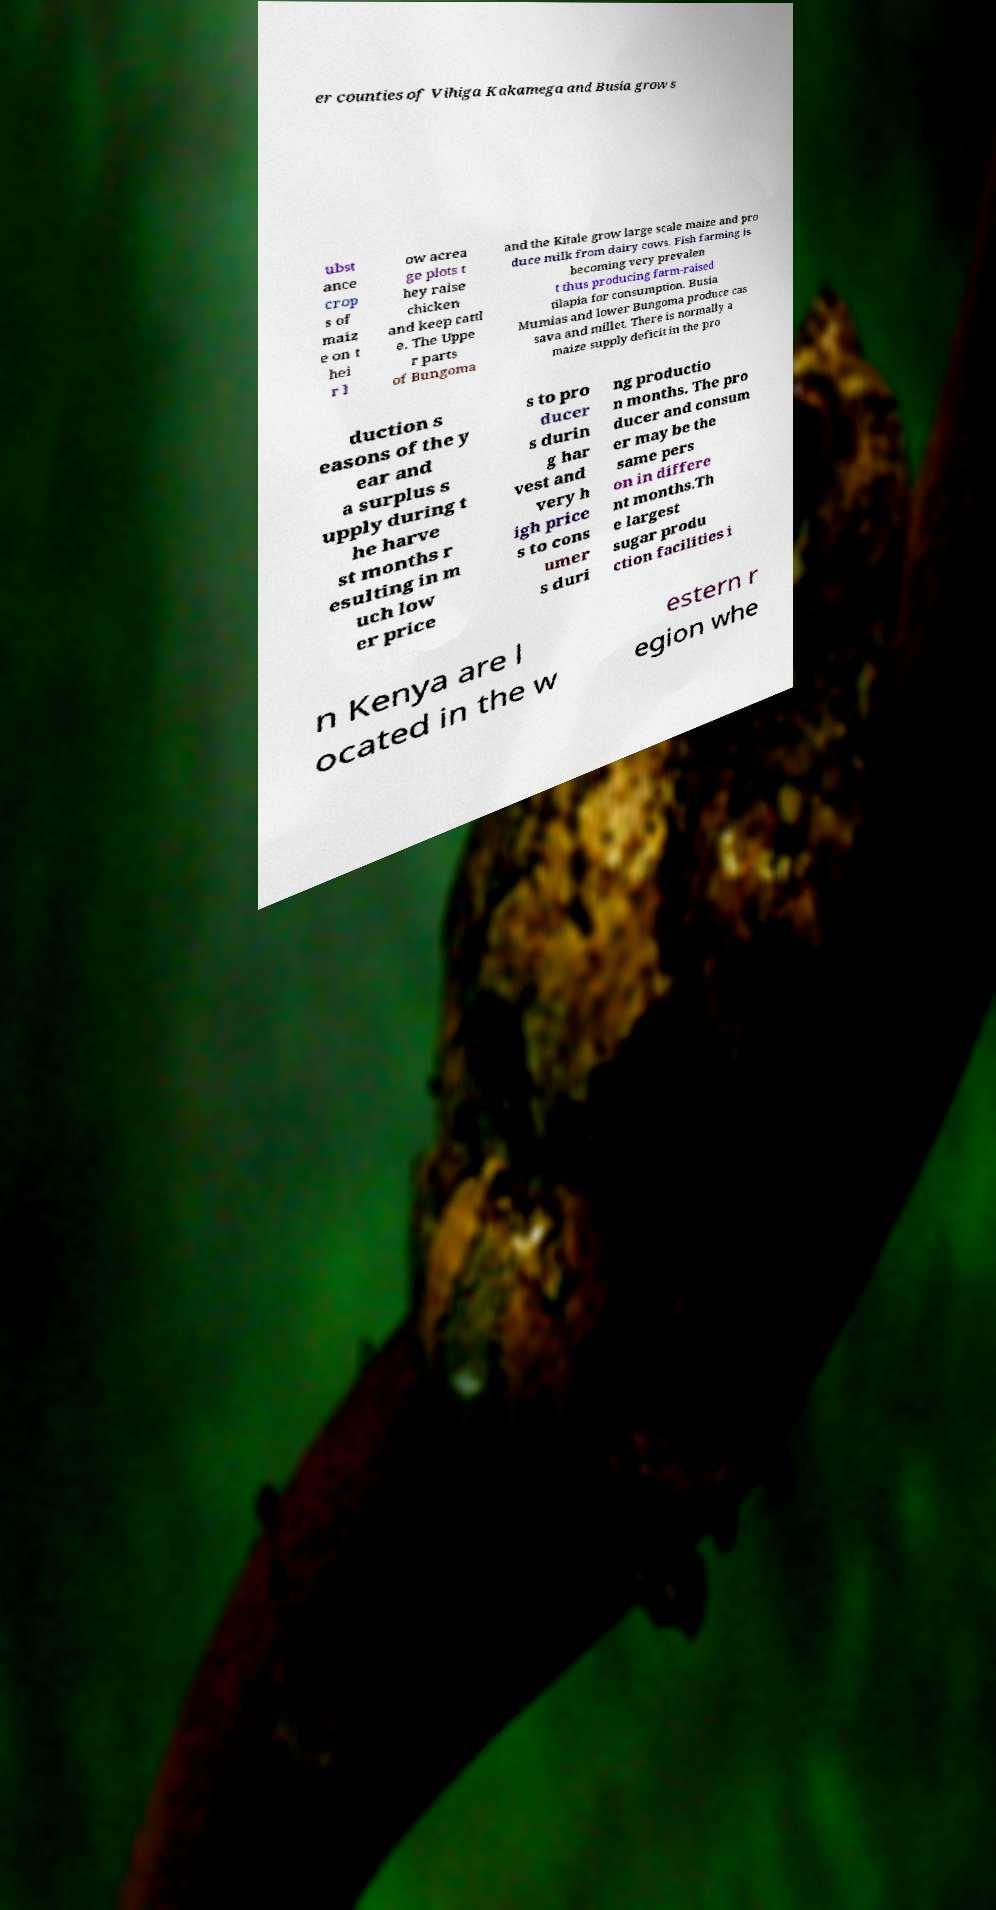Could you assist in decoding the text presented in this image and type it out clearly? er counties of Vihiga Kakamega and Busia grow s ubst ance crop s of maiz e on t hei r l ow acrea ge plots t hey raise chicken and keep cattl e. The Uppe r parts of Bungoma and the Kitale grow large scale maize and pro duce milk from dairy cows. Fish farming is becoming very prevalen t thus producing farm-raised tilapia for consumption. Busia Mumias and lower Bungoma produce cas sava and millet. There is normally a maize supply deficit in the pro duction s easons of the y ear and a surplus s upply during t he harve st months r esulting in m uch low er price s to pro ducer s durin g har vest and very h igh price s to cons umer s duri ng productio n months. The pro ducer and consum er may be the same pers on in differe nt months.Th e largest sugar produ ction facilities i n Kenya are l ocated in the w estern r egion whe 